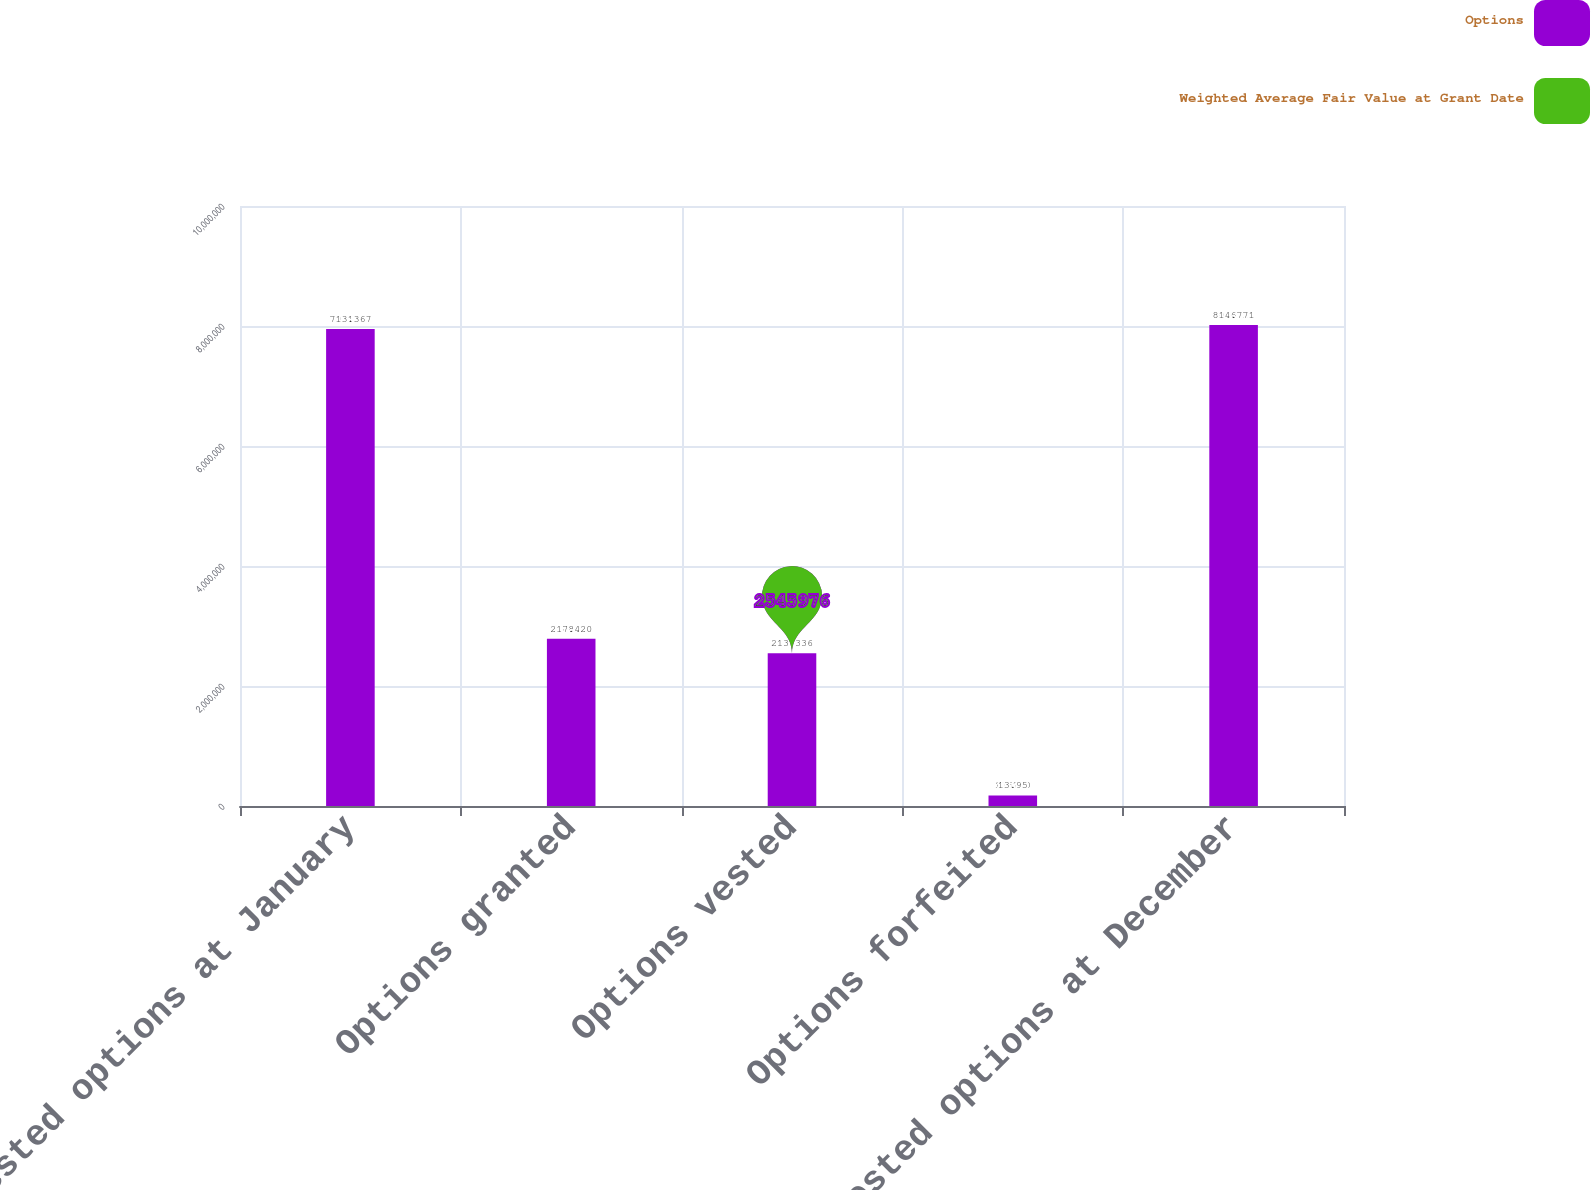<chart> <loc_0><loc_0><loc_500><loc_500><stacked_bar_chart><ecel><fcel>Non-vested options at January<fcel>Options granted<fcel>Options vested<fcel>Options forfeited<fcel>Non-vested options at December<nl><fcel>Options<fcel>7.95118e+06<fcel>2.788e+06<fcel>2.54598e+06<fcel>176280<fcel>8.01692e+06<nl><fcel>Weighted Average Fair Value at Grant Date<fcel>13.36<fcel>17.42<fcel>13.33<fcel>13.95<fcel>14.77<nl></chart> 